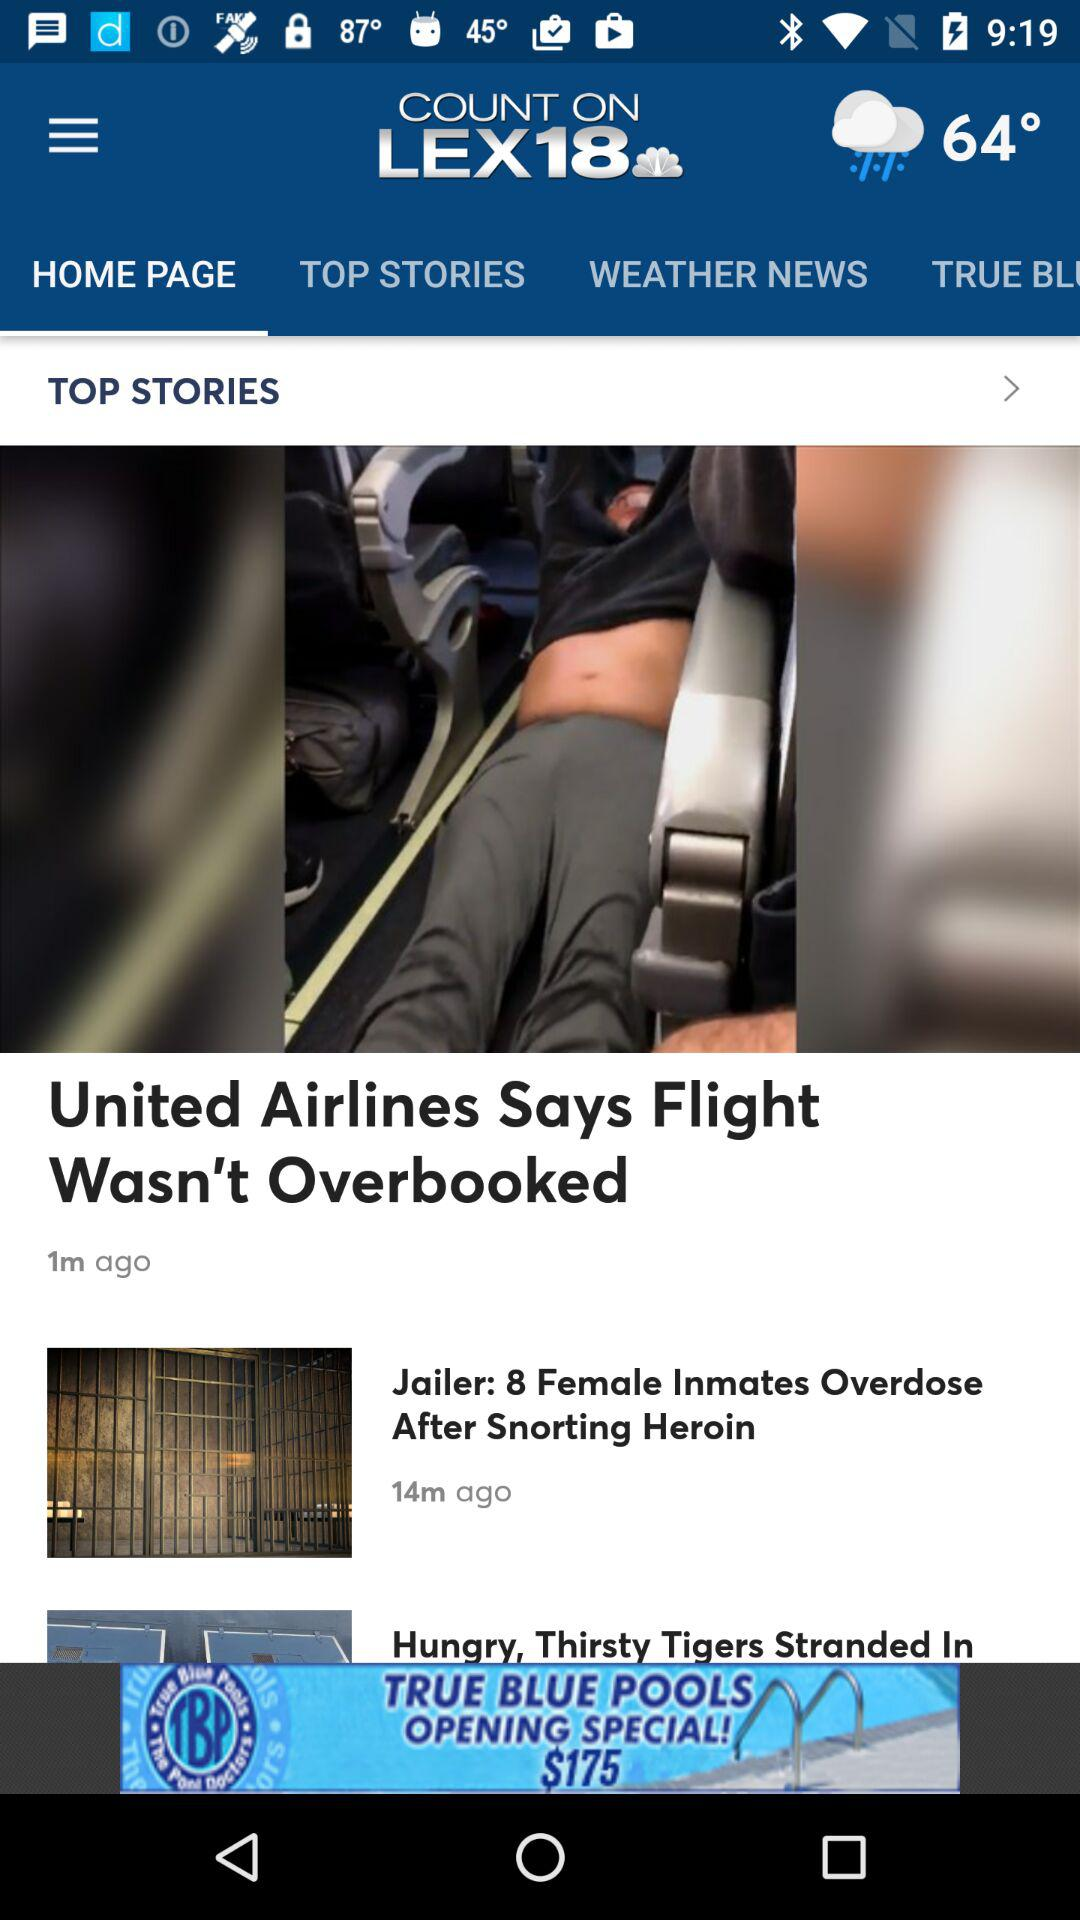When was the article "United Airlines Says Flight Wasn't Overbooked" posted? The article was posted 1 minute ago. 